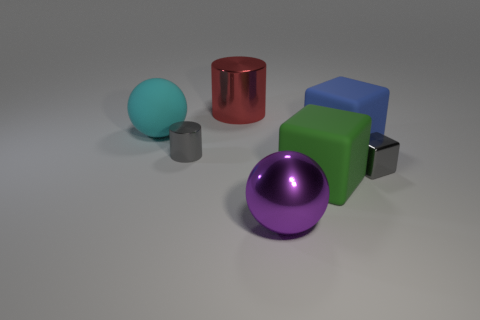What material is the green block?
Keep it short and to the point. Rubber. Is the blue object made of the same material as the ball that is behind the green thing?
Provide a short and direct response. Yes. There is a large thing behind the big matte object behind the large blue matte thing; what color is it?
Provide a short and direct response. Red. How big is the thing that is on the left side of the large metal cylinder and right of the cyan matte ball?
Offer a very short reply. Small. What number of other objects are the same shape as the large purple shiny object?
Give a very brief answer. 1. There is a blue thing; is it the same shape as the small gray shiny thing right of the big green rubber thing?
Make the answer very short. Yes. There is a small gray metal cylinder; how many big rubber cubes are in front of it?
Offer a very short reply. 1. Does the shiny object to the left of the big red cylinder have the same shape as the large red object?
Ensure brevity in your answer.  Yes. What color is the metal cylinder in front of the cyan thing?
Keep it short and to the point. Gray. What is the shape of the cyan thing that is the same material as the big green cube?
Provide a short and direct response. Sphere. 